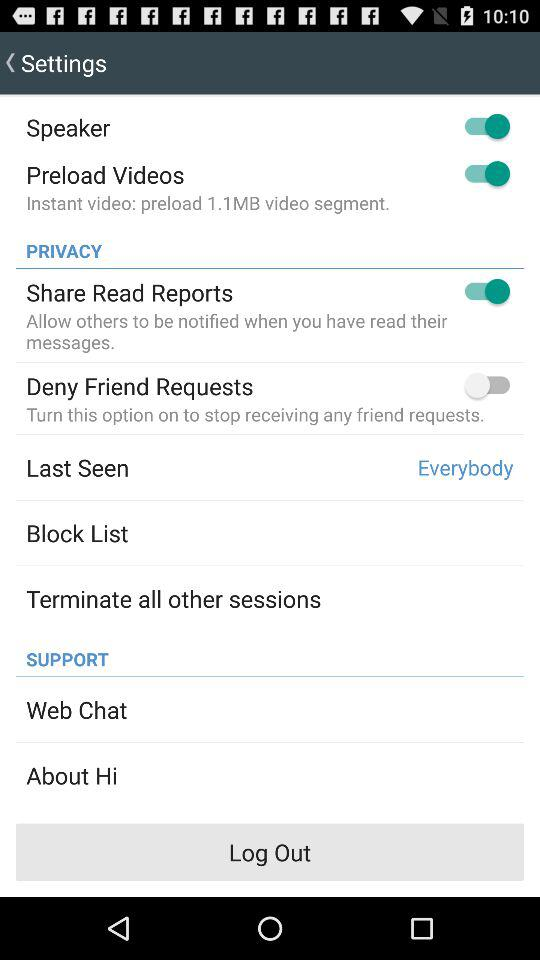What is the status of "Share Read Reports"? The status is "on". 